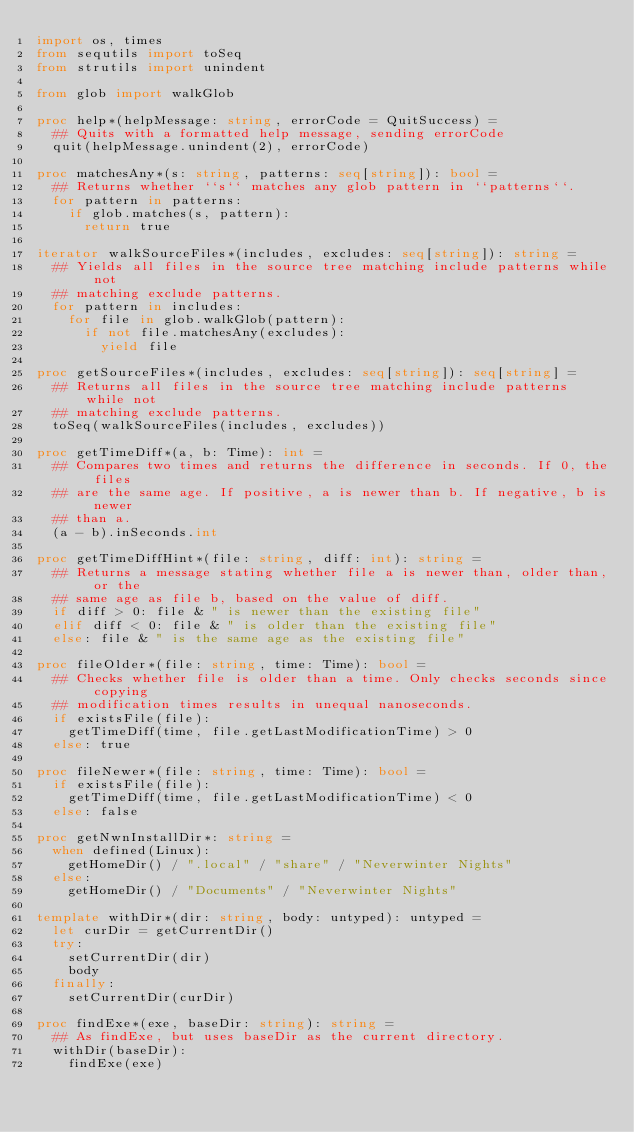Convert code to text. <code><loc_0><loc_0><loc_500><loc_500><_Nim_>import os, times
from sequtils import toSeq
from strutils import unindent

from glob import walkGlob

proc help*(helpMessage: string, errorCode = QuitSuccess) =
  ## Quits with a formatted help message, sending errorCode
  quit(helpMessage.unindent(2), errorCode)

proc matchesAny*(s: string, patterns: seq[string]): bool =
  ## Returns whether ``s`` matches any glob pattern in ``patterns``.
  for pattern in patterns:
    if glob.matches(s, pattern):
      return true

iterator walkSourceFiles*(includes, excludes: seq[string]): string =
  ## Yields all files in the source tree matching include patterns while not
  ## matching exclude patterns.
  for pattern in includes:
    for file in glob.walkGlob(pattern):
      if not file.matchesAny(excludes):
        yield file

proc getSourceFiles*(includes, excludes: seq[string]): seq[string] =
  ## Returns all files in the source tree matching include patterns while not
  ## matching exclude patterns.
  toSeq(walkSourceFiles(includes, excludes))

proc getTimeDiff*(a, b: Time): int =
  ## Compares two times and returns the difference in seconds. If 0, the files
  ## are the same age. If positive, a is newer than b. If negative, b is newer
  ## than a.
  (a - b).inSeconds.int

proc getTimeDiffHint*(file: string, diff: int): string =
  ## Returns a message stating whether file a is newer than, older than, or the
  ## same age as file b, based on the value of diff.
  if diff > 0: file & " is newer than the existing file"
  elif diff < 0: file & " is older than the existing file"
  else: file & " is the same age as the existing file"

proc fileOlder*(file: string, time: Time): bool =
  ## Checks whether file is older than a time. Only checks seconds since copying
  ## modification times results in unequal nanoseconds.
  if existsFile(file):
    getTimeDiff(time, file.getLastModificationTime) > 0
  else: true

proc fileNewer*(file: string, time: Time): bool =
  if existsFile(file):
    getTimeDiff(time, file.getLastModificationTime) < 0
  else: false

proc getNwnInstallDir*: string =
  when defined(Linux):
    getHomeDir() / ".local" / "share" / "Neverwinter Nights"
  else:
    getHomeDir() / "Documents" / "Neverwinter Nights"

template withDir*(dir: string, body: untyped): untyped =
  let curDir = getCurrentDir()
  try:
    setCurrentDir(dir)
    body
  finally:
    setCurrentDir(curDir)

proc findExe*(exe, baseDir: string): string =
  ## As findExe, but uses baseDir as the current directory.
  withDir(baseDir):
    findExe(exe)
</code> 